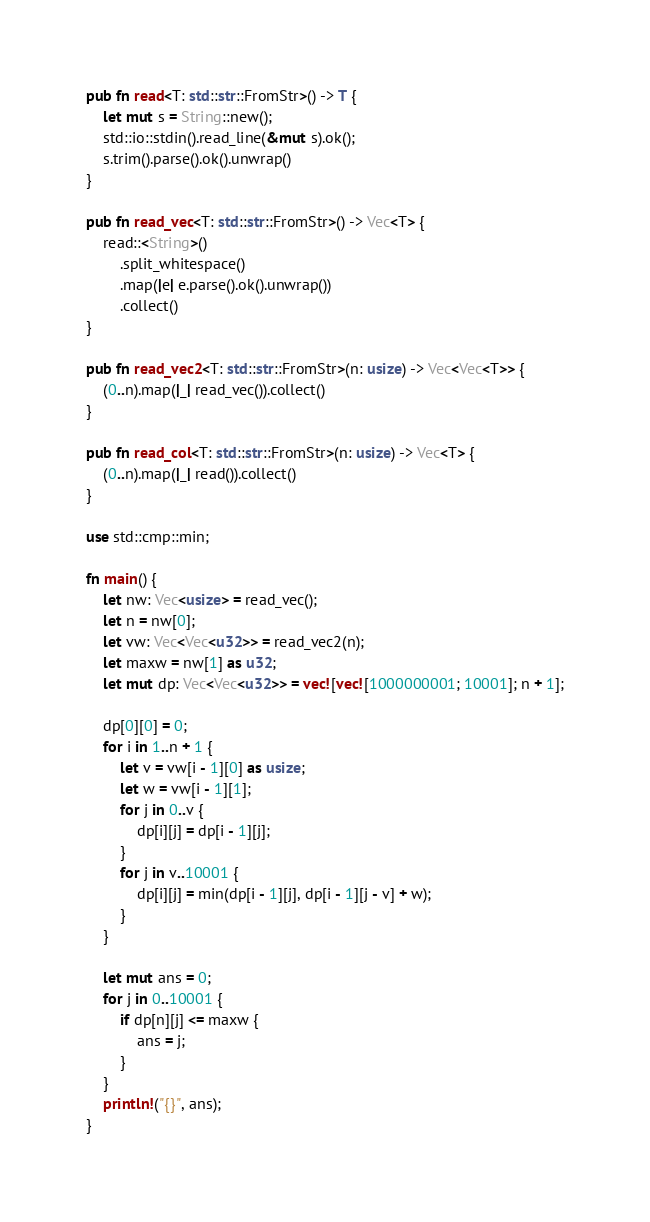Convert code to text. <code><loc_0><loc_0><loc_500><loc_500><_Rust_>pub fn read<T: std::str::FromStr>() -> T {
    let mut s = String::new();
    std::io::stdin().read_line(&mut s).ok();
    s.trim().parse().ok().unwrap()
}

pub fn read_vec<T: std::str::FromStr>() -> Vec<T> {
    read::<String>()
        .split_whitespace()
        .map(|e| e.parse().ok().unwrap())
        .collect()
}

pub fn read_vec2<T: std::str::FromStr>(n: usize) -> Vec<Vec<T>> {
    (0..n).map(|_| read_vec()).collect()
}

pub fn read_col<T: std::str::FromStr>(n: usize) -> Vec<T> {
    (0..n).map(|_| read()).collect()
}

use std::cmp::min;

fn main() {
    let nw: Vec<usize> = read_vec();
    let n = nw[0];
    let vw: Vec<Vec<u32>> = read_vec2(n);
    let maxw = nw[1] as u32;
    let mut dp: Vec<Vec<u32>> = vec![vec![1000000001; 10001]; n + 1];

    dp[0][0] = 0;
    for i in 1..n + 1 {
        let v = vw[i - 1][0] as usize;
        let w = vw[i - 1][1];
        for j in 0..v {
            dp[i][j] = dp[i - 1][j];
        }
        for j in v..10001 {
            dp[i][j] = min(dp[i - 1][j], dp[i - 1][j - v] + w);
        }
    }

    let mut ans = 0;
    for j in 0..10001 {
        if dp[n][j] <= maxw {
            ans = j;
        }
    }
    println!("{}", ans);
}

</code> 